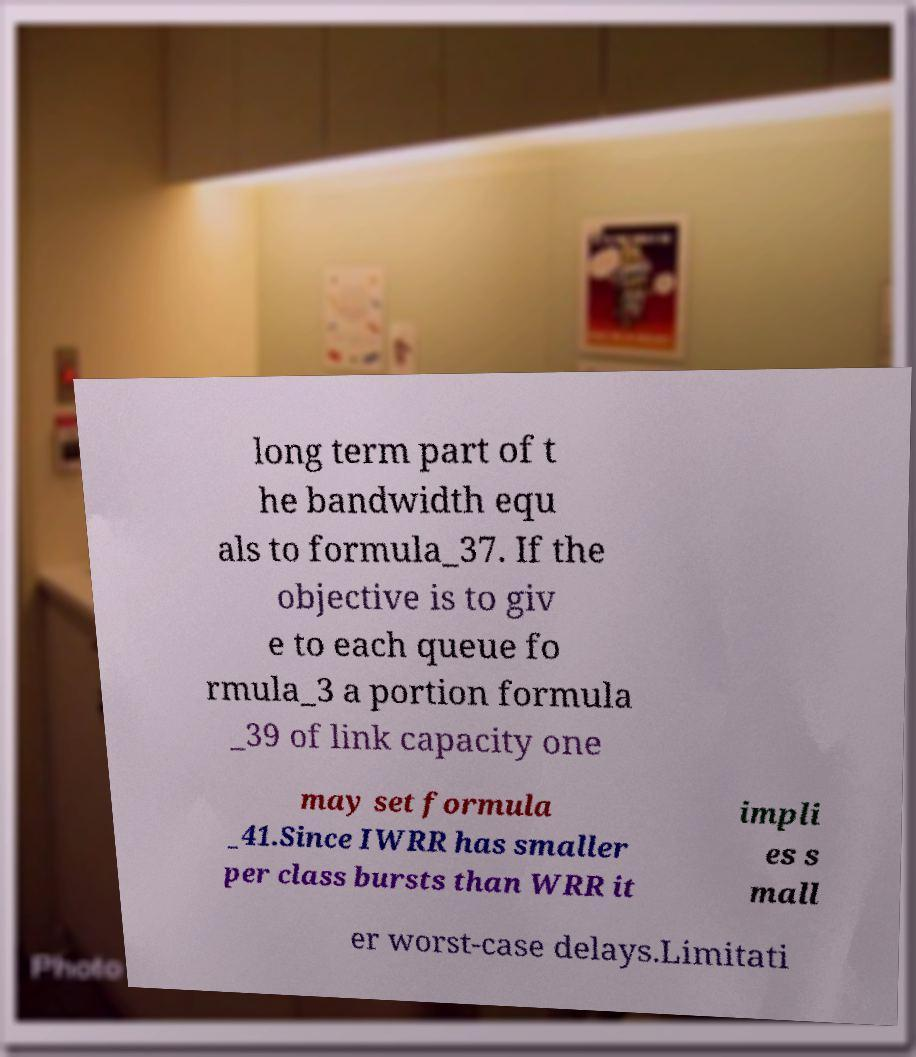For documentation purposes, I need the text within this image transcribed. Could you provide that? long term part of t he bandwidth equ als to formula_37. If the objective is to giv e to each queue fo rmula_3 a portion formula _39 of link capacity one may set formula _41.Since IWRR has smaller per class bursts than WRR it impli es s mall er worst-case delays.Limitati 